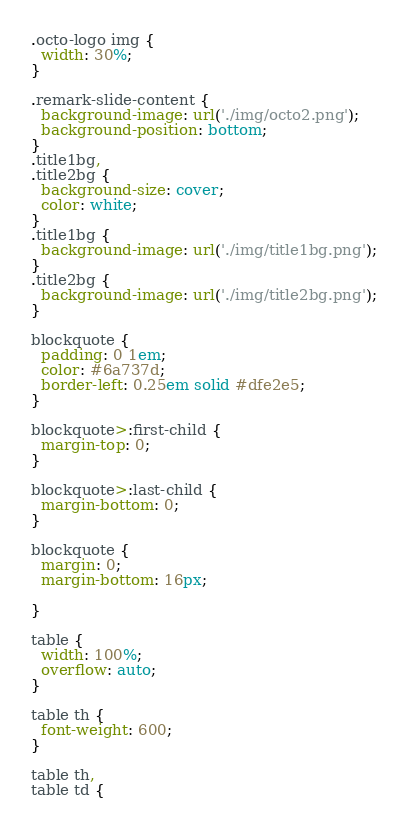<code> <loc_0><loc_0><loc_500><loc_500><_CSS_>.octo-logo img {
  width: 30%;
}

.remark-slide-content {
  background-image: url('./img/octo2.png');
  background-position: bottom;
}
.title1bg,
.title2bg {
  background-size: cover;
  color: white;
}
.title1bg {
  background-image: url('./img/title1bg.png');
}
.title2bg {
  background-image: url('./img/title2bg.png');
}

blockquote {
  padding: 0 1em;
  color: #6a737d;
  border-left: 0.25em solid #dfe2e5;
}

blockquote>:first-child {
  margin-top: 0;
}

blockquote>:last-child {
  margin-bottom: 0;
}

blockquote {
  margin: 0;
  margin-bottom: 16px;

}

table {
  width: 100%;
  overflow: auto;
}

table th {
  font-weight: 600;
}

table th,
table td {</code> 